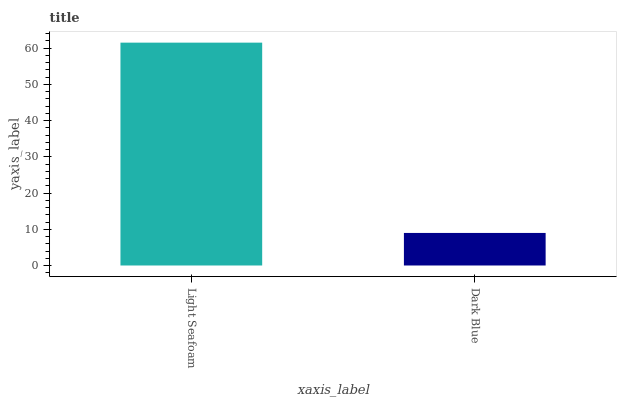Is Dark Blue the maximum?
Answer yes or no. No. Is Light Seafoam greater than Dark Blue?
Answer yes or no. Yes. Is Dark Blue less than Light Seafoam?
Answer yes or no. Yes. Is Dark Blue greater than Light Seafoam?
Answer yes or no. No. Is Light Seafoam less than Dark Blue?
Answer yes or no. No. Is Light Seafoam the high median?
Answer yes or no. Yes. Is Dark Blue the low median?
Answer yes or no. Yes. Is Dark Blue the high median?
Answer yes or no. No. Is Light Seafoam the low median?
Answer yes or no. No. 